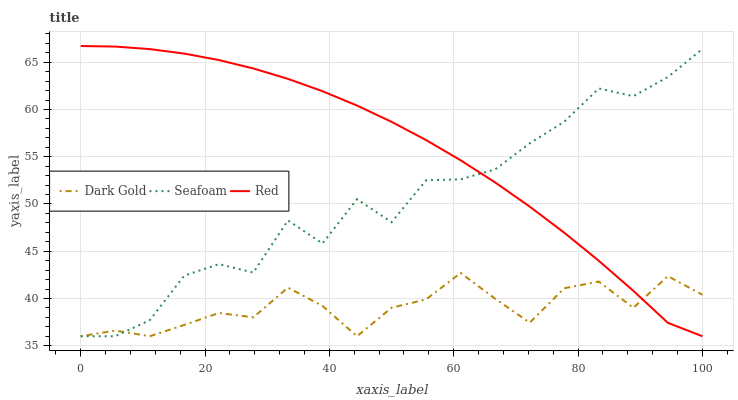Does Dark Gold have the minimum area under the curve?
Answer yes or no. Yes. Does Red have the maximum area under the curve?
Answer yes or no. Yes. Does Red have the minimum area under the curve?
Answer yes or no. No. Does Dark Gold have the maximum area under the curve?
Answer yes or no. No. Is Red the smoothest?
Answer yes or no. Yes. Is Seafoam the roughest?
Answer yes or no. Yes. Is Dark Gold the smoothest?
Answer yes or no. No. Is Dark Gold the roughest?
Answer yes or no. No. Does Seafoam have the lowest value?
Answer yes or no. Yes. Does Red have the highest value?
Answer yes or no. Yes. Does Dark Gold have the highest value?
Answer yes or no. No. Does Dark Gold intersect Seafoam?
Answer yes or no. Yes. Is Dark Gold less than Seafoam?
Answer yes or no. No. Is Dark Gold greater than Seafoam?
Answer yes or no. No. 